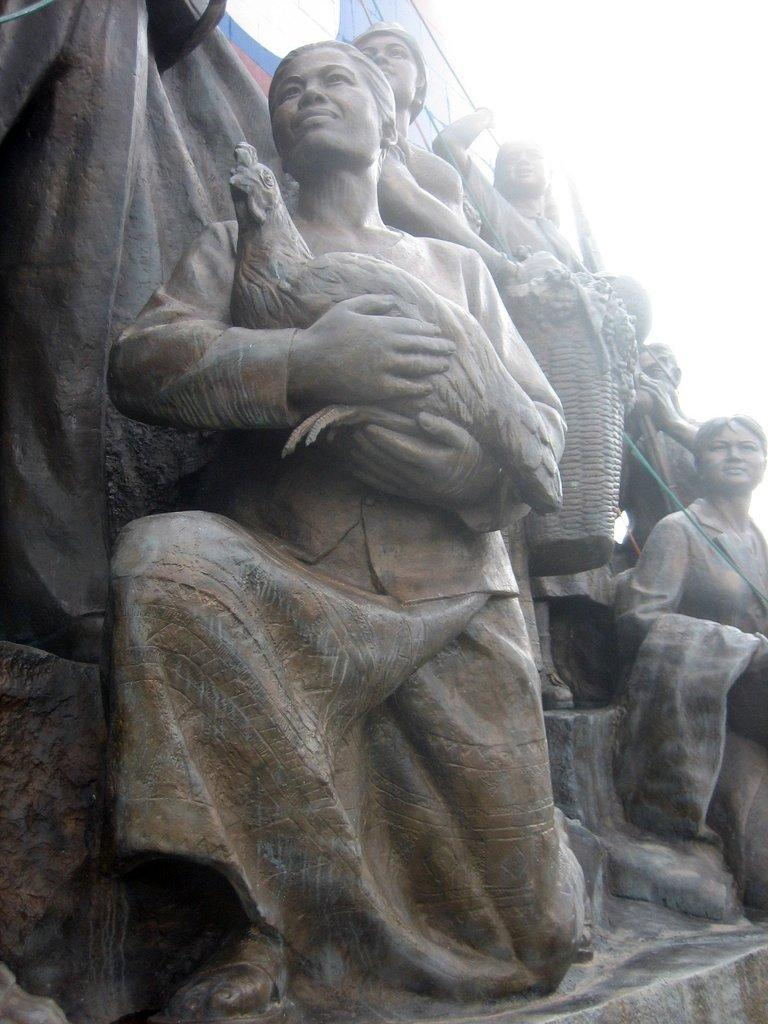What is depicted on the stone in the image? There are statues carved on the stone in the image. How would you describe the sky in the image? The sky is cloudy in the image. What is the woman in the image holding? The woman in the image is holding a hen in her hand. What color is the orange in the image? There is no orange present in the image. Is there any blood visible in the image? No, there is no blood visible in the image. What type of vegetable is being used as a prop in the image? There is no vegetable present in the image. 